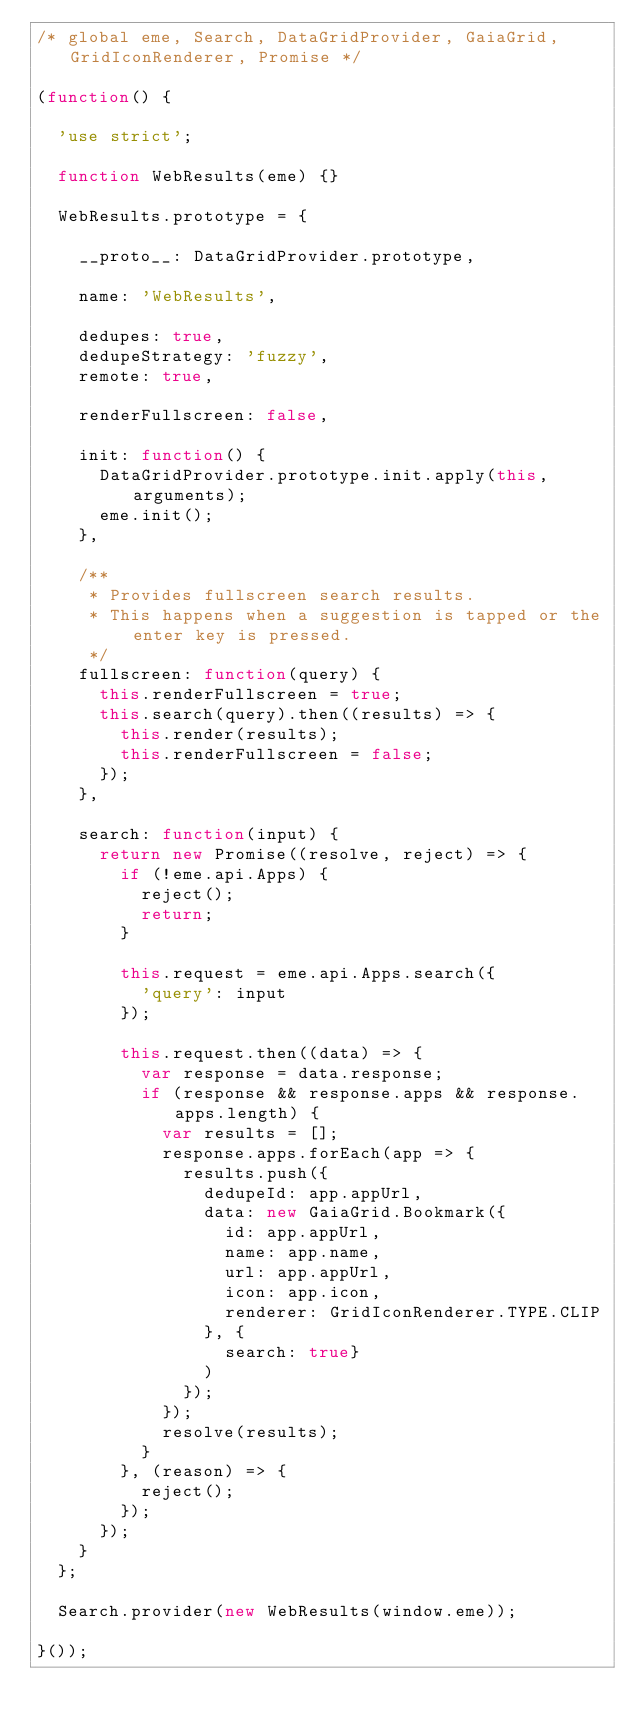Convert code to text. <code><loc_0><loc_0><loc_500><loc_500><_JavaScript_>/* global eme, Search, DataGridProvider, GaiaGrid, GridIconRenderer, Promise */

(function() {

  'use strict';

  function WebResults(eme) {}

  WebResults.prototype = {

    __proto__: DataGridProvider.prototype,

    name: 'WebResults',

    dedupes: true,
    dedupeStrategy: 'fuzzy',
    remote: true,

    renderFullscreen: false,

    init: function() {
      DataGridProvider.prototype.init.apply(this, arguments);
      eme.init();
    },

    /**
     * Provides fullscreen search results.
     * This happens when a suggestion is tapped or the enter key is pressed.
     */
    fullscreen: function(query) {
      this.renderFullscreen = true;
      this.search(query).then((results) => {
        this.render(results);
        this.renderFullscreen = false;
      });
    },

    search: function(input) {
      return new Promise((resolve, reject) => {
        if (!eme.api.Apps) {
          reject();
          return;
        }

        this.request = eme.api.Apps.search({
          'query': input
        });

        this.request.then((data) => {
          var response = data.response;
          if (response && response.apps && response.apps.length) {
            var results = [];
            response.apps.forEach(app => {
              results.push({
                dedupeId: app.appUrl,
                data: new GaiaGrid.Bookmark({
                  id: app.appUrl,
                  name: app.name,
                  url: app.appUrl,
                  icon: app.icon,
                  renderer: GridIconRenderer.TYPE.CLIP
                }, {
                  search: true}
                )
              });
            });
            resolve(results);
          }
        }, (reason) => {
          reject();
        });
      });
    }
  };

  Search.provider(new WebResults(window.eme));

}());
</code> 